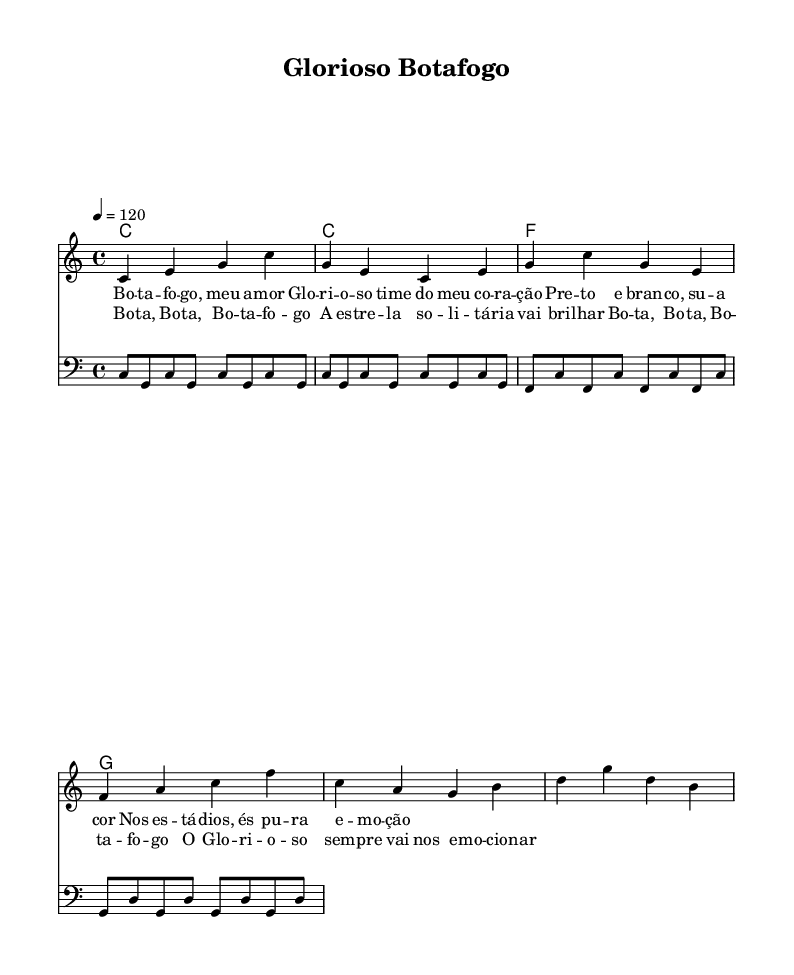What is the key signature of this music? The key signature is C major, which is indicated by the absence of sharps or flats in the staff.
Answer: C major What is the time signature of this music? The time signature is 4/4, shown at the beginning of the score, indicating four beats per measure.
Answer: 4/4 What is the tempo marking for this piece? The tempo is marked as 4 = 120, which indicates a moderate pace of 120 beats per minute.
Answer: 120 How many measures are in the chorus section? The chorus section consists of two measures, as indicated by the lyrics contained within two sets of staff lines.
Answer: 2 What is the note value of the first note in the melody? The first note in the melody is a quarter note (noted as 'c4'), as indicated by the '4' attached to the note name.
Answer: Quarter note What are the lyrics for the first line of the verse? The first line of the verse lyrics reads: "Bo -- ta -- fo -- go, meu a -- mor," directly taken from the lyric mode notation of the score.
Answer: Bo -- ta -- fo -- go, meu a -- mor How many different chords are used in the harmonies? There are three different chords (C, F, G) that are used in the harmony section, as noted in the chord mode section.
Answer: 3 